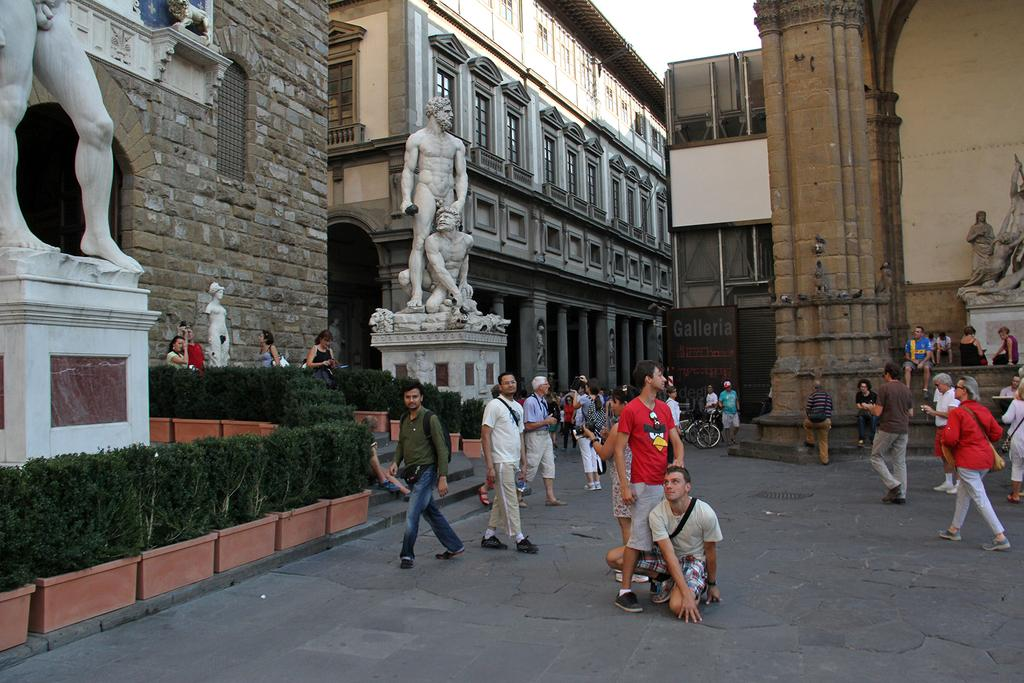What are the people in the image doing? The people in the image are walking on the road. What can be seen in the background of the image? In the background of the image, there are sculptures, plants, boards, and buildings. What type of receipt can be seen in the image? There is no receipt present in the image. What key is used to unlock the door in the image? There is no door or key present in the image. 